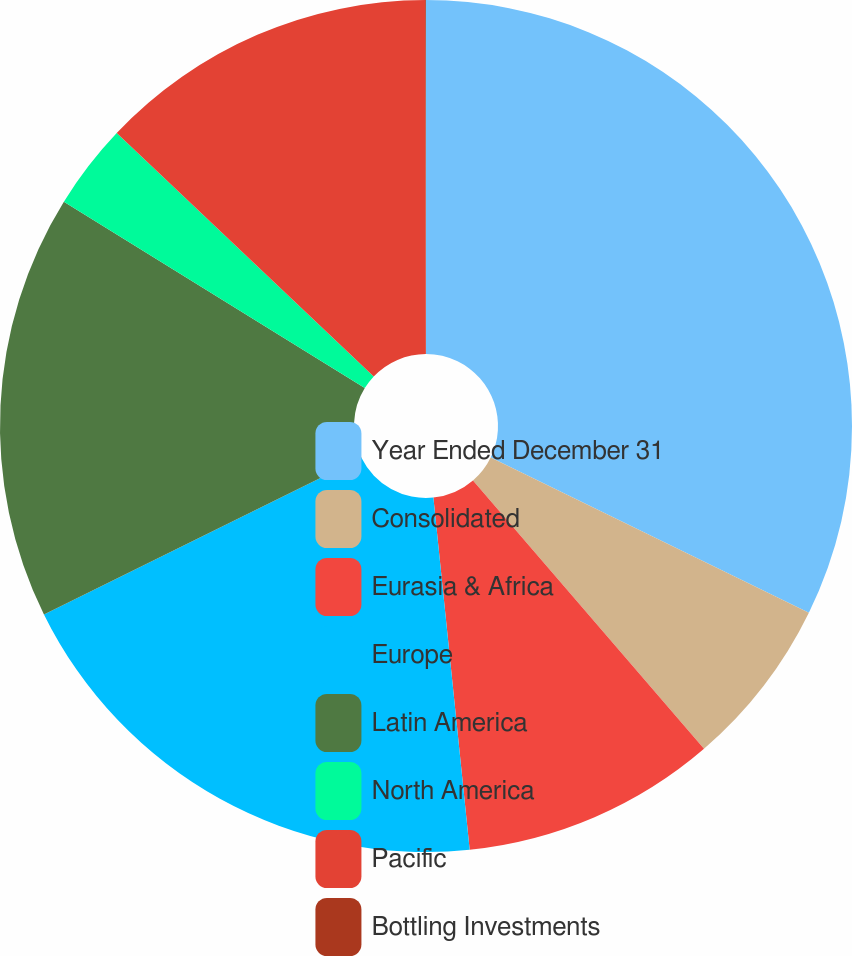Convert chart. <chart><loc_0><loc_0><loc_500><loc_500><pie_chart><fcel>Year Ended December 31<fcel>Consolidated<fcel>Eurasia & Africa<fcel>Europe<fcel>Latin America<fcel>North America<fcel>Pacific<fcel>Bottling Investments<nl><fcel>32.22%<fcel>6.46%<fcel>9.68%<fcel>19.34%<fcel>16.12%<fcel>3.24%<fcel>12.9%<fcel>0.03%<nl></chart> 